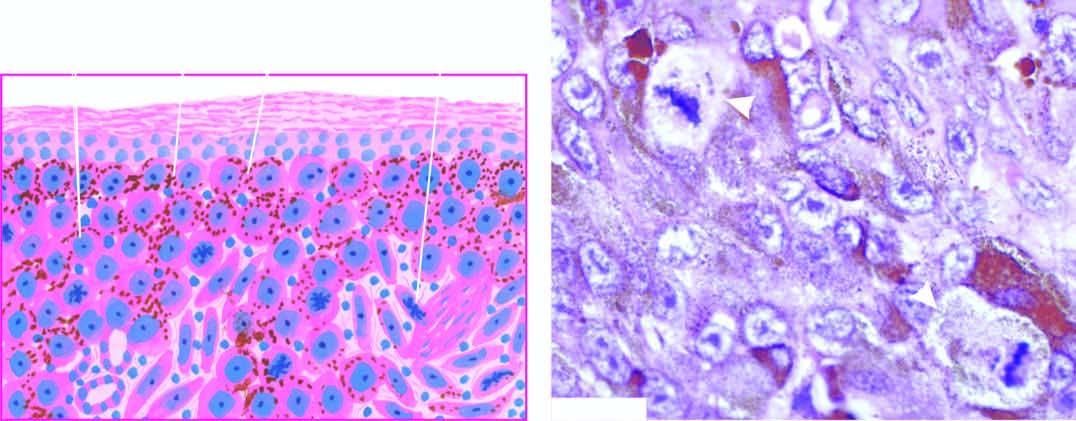what does photomicrograph show?
Answer the question using a single word or phrase. A prominent atypical mitotic figure 